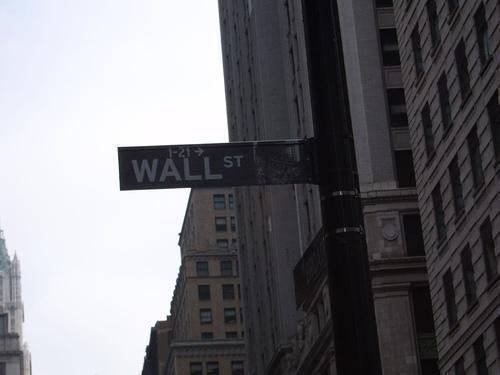How many signs are there?
Give a very brief answer. 2. 